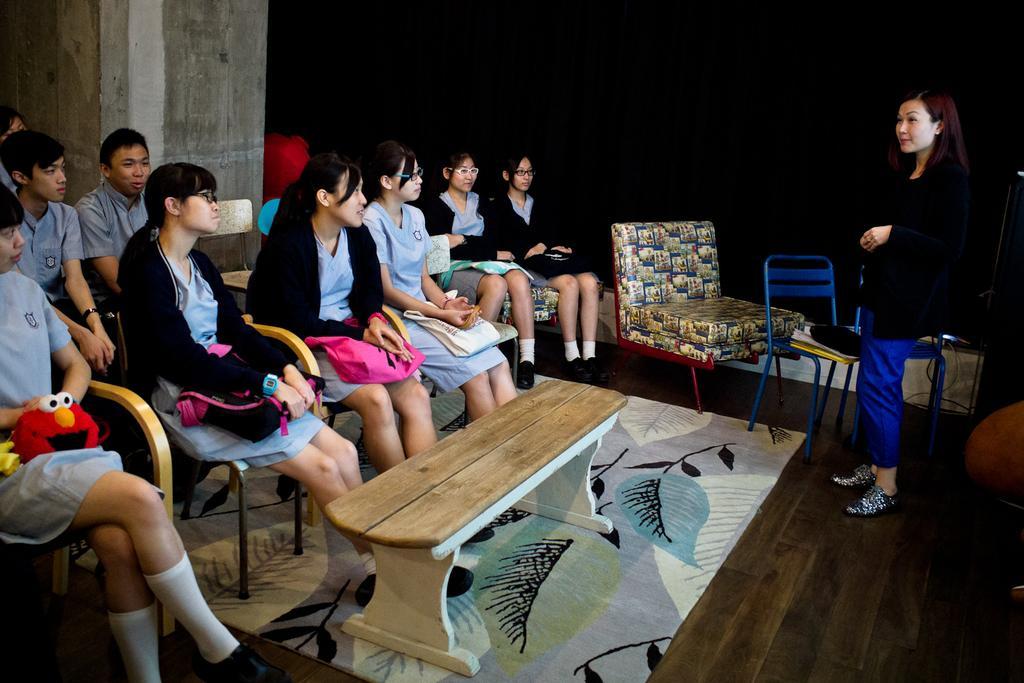In one or two sentences, can you explain what this image depicts? In this picture we can see a group of students sitting on the chairs with bags and looking at a lady standing in front of them. Here we can see a wooden table, chairs and a carpet on the wooden floor. 